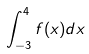Convert formula to latex. <formula><loc_0><loc_0><loc_500><loc_500>\int _ { - 3 } ^ { 4 } f ( x ) d x</formula> 